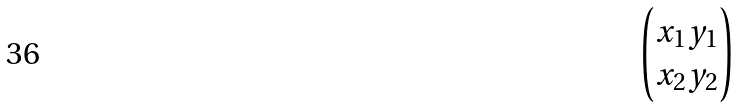Convert formula to latex. <formula><loc_0><loc_0><loc_500><loc_500>\begin{pmatrix} x _ { 1 } y _ { 1 } \\ x _ { 2 } y _ { 2 } \end{pmatrix}</formula> 